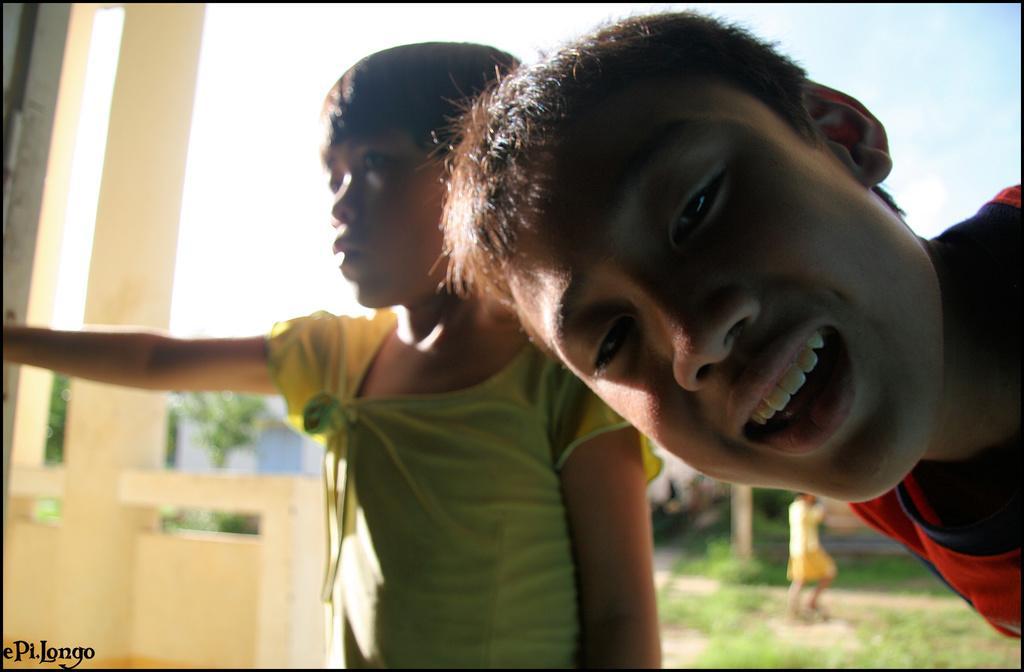Please provide a concise description of this image. In this image in the foreground there is one boy and one girl standing, and in the background there are pillars, wall, buildings, trees, grass and one girl is standing. And at the top there is sky. 